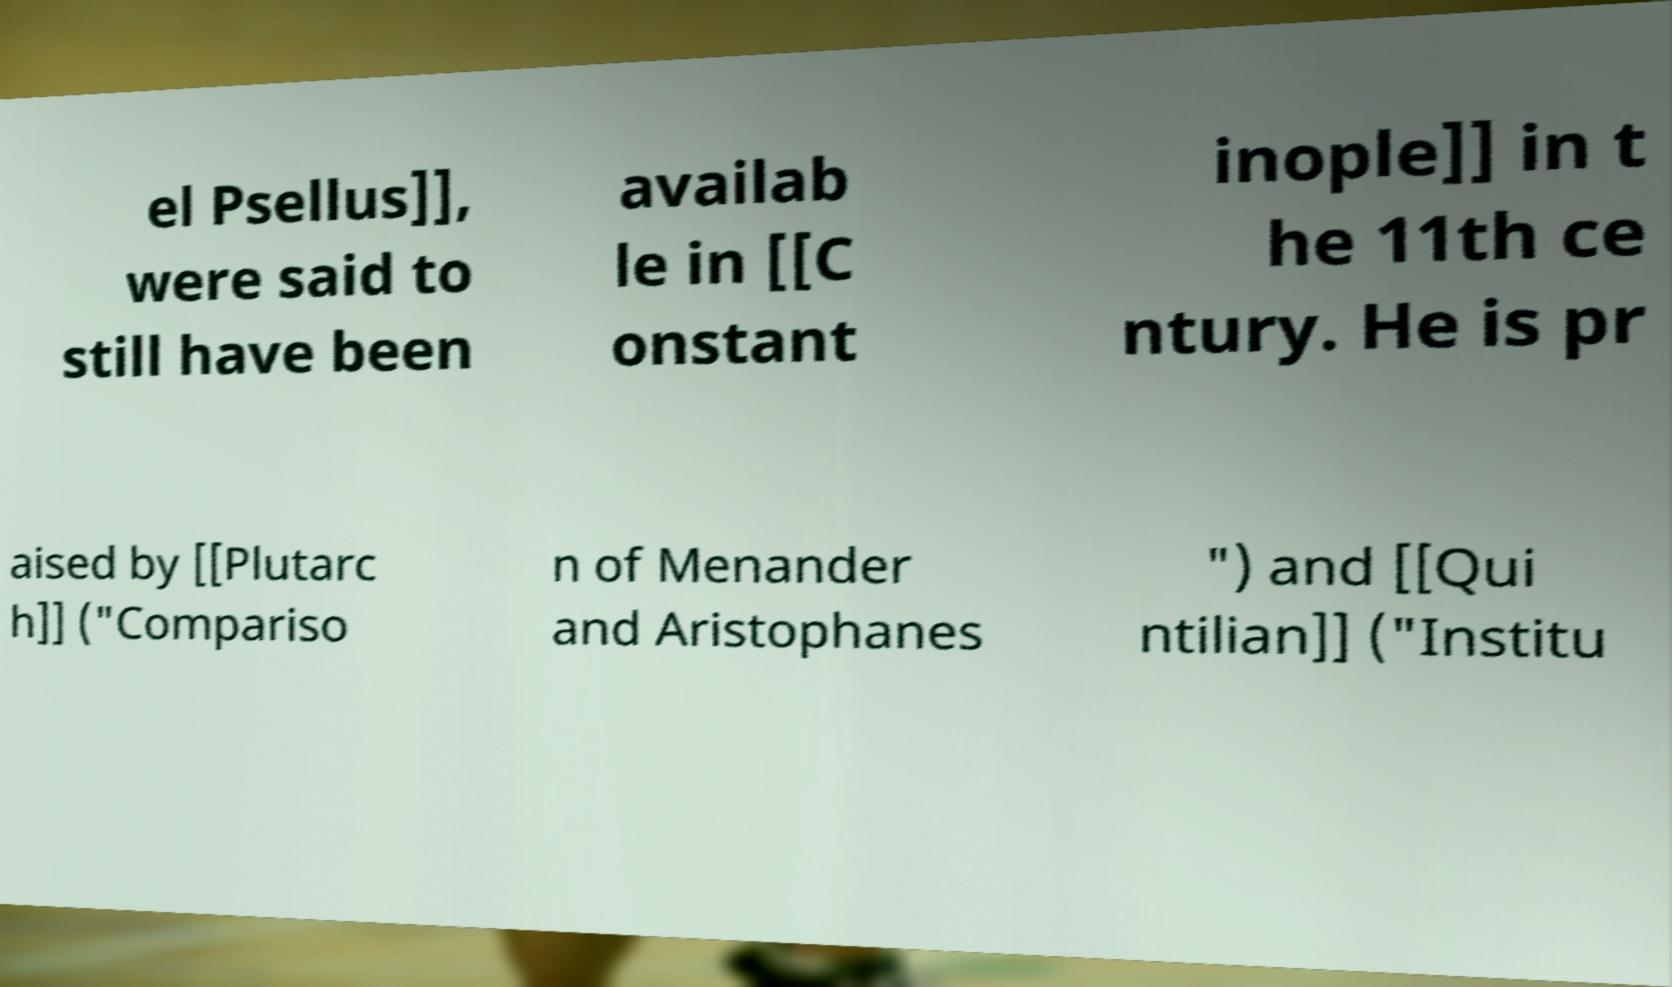Could you extract and type out the text from this image? el Psellus]], were said to still have been availab le in [[C onstant inople]] in t he 11th ce ntury. He is pr aised by [[Plutarc h]] ("Compariso n of Menander and Aristophanes ") and [[Qui ntilian]] ("Institu 